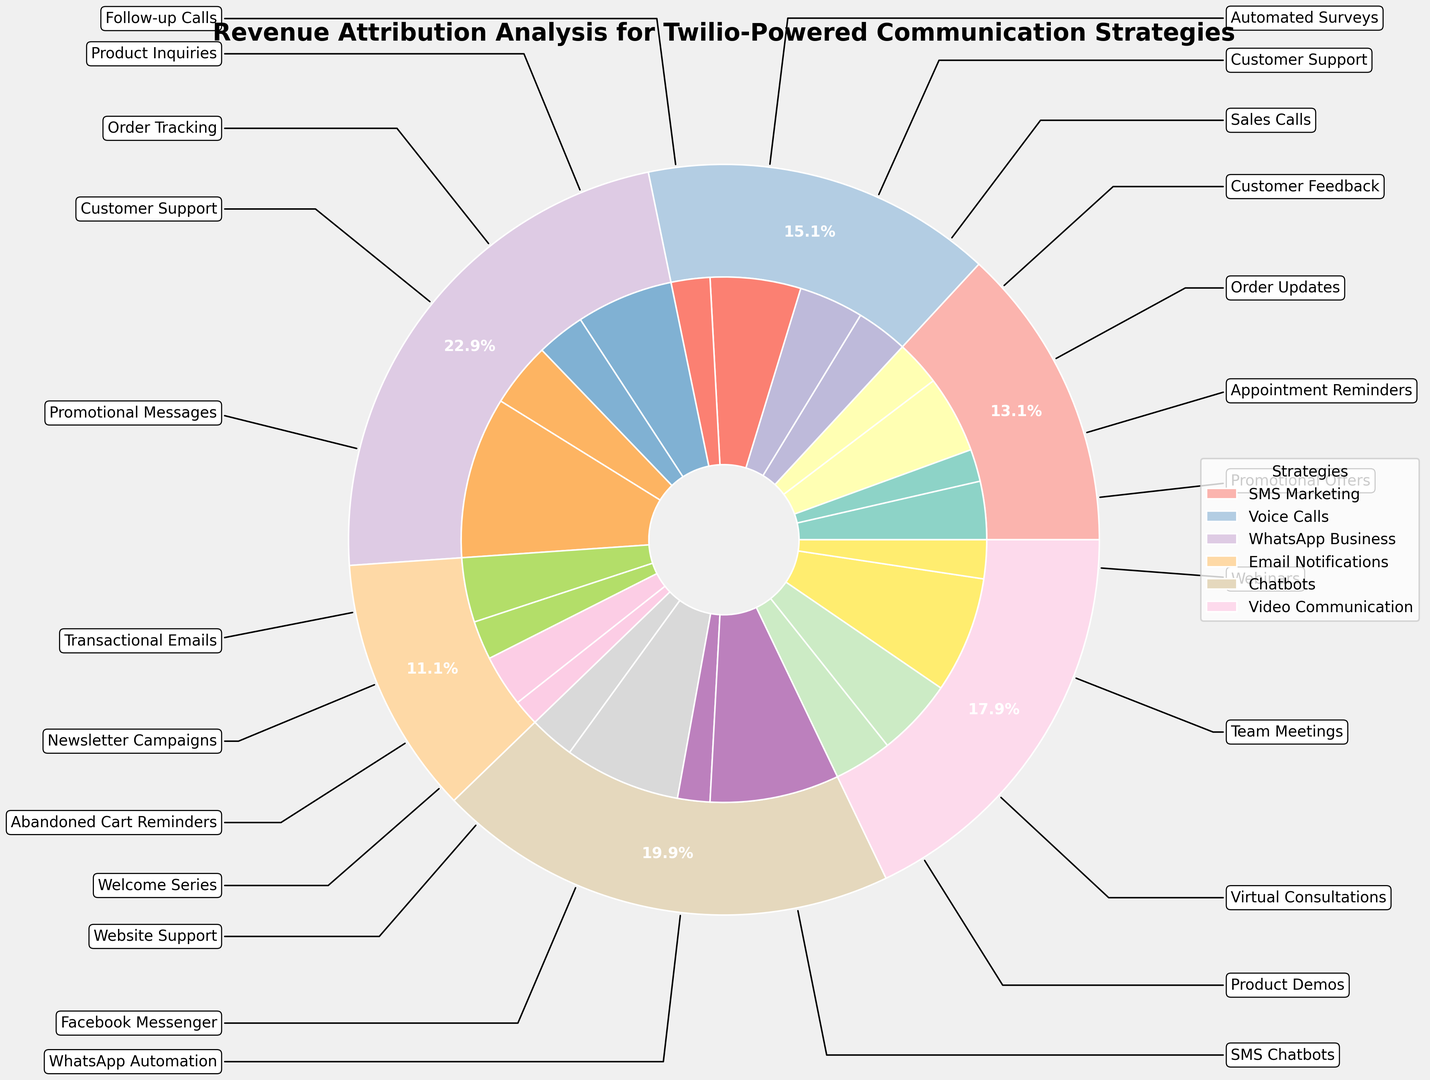Which strategy generates the highest revenue? Look at the outer pie chart, the segment with the largest percentage represents the strategy generating the highest revenue.
Answer: SMS Marketing How much total revenue is generated from the Voice Calls strategy? Check the sum of the individual subcategories ('Sales Calls', 'Customer Support', 'Automated Surveys', and 'Follow-up Calls') within the Voice Calls section in the inner pie chart. Add these values: 200,000 + 180,000 + 70,000 + 50,000.
Answer: 500,000 Which strategy’s subcategory contributes the most individually? Identify the largest segment in the inner pie chart. The 'Promotional Offers' under SMS Marketing looks notably bigger compared to other subcategories.
Answer: Promotional Offers How does the revenue from 'Transactional Emails' in the Email Notifications strategy compare to 'Product Demos' in the Video Communication strategy? Refer to both subcategories 'Transactional Emails' and 'Product Demos' in the inner pie chart; compare their estimated revenue by size.
Answer: Transactional Emails generates more revenue than Product Demos What percentage of total revenue is generated from the Chatbots strategy? Check the outer pie chart for the Chatbots segment and identify the percentage mark beside it.
Answer: 13.4% What's the difference in revenue between 'Sales Calls' and 'Automated Surveys' under the Voice Calls strategy? Subtract the revenue of 'Automated Surveys' from 'Sales Calls' (200,000 - 70,000).
Answer: 130,000 Which subcategory of WhatsApp Business strategy generates the least revenue? Among 'Product Inquiries', 'Order Tracking', 'Customer Support', and 'Promotional Messages' in the inner pie chart within WhatsApp Business, 'Promotional Messages' seems to be the smallest segment.
Answer: Promotional Messages What’s the combined revenue of the ‘Appointment Reminders’ and ‘Order Updates’ subcategories within SMS Marketing? Add the revenue from both subcategories (150,000 + 100,000).
Answer: 250,000 Is the revenue from 'Virtual Consultations' in the Video Communication strategy greater than the revenue from 'SMS Chatbots' in the Chatbots strategy? Compare the two inner segments visually; Virtual Consultations appears larger than SMS Chatbots.
Answer: Yes How many subcategories are there in total for all strategies combined? Count the individual segments in the inner pie chart across all strategies.
Answer: 20 